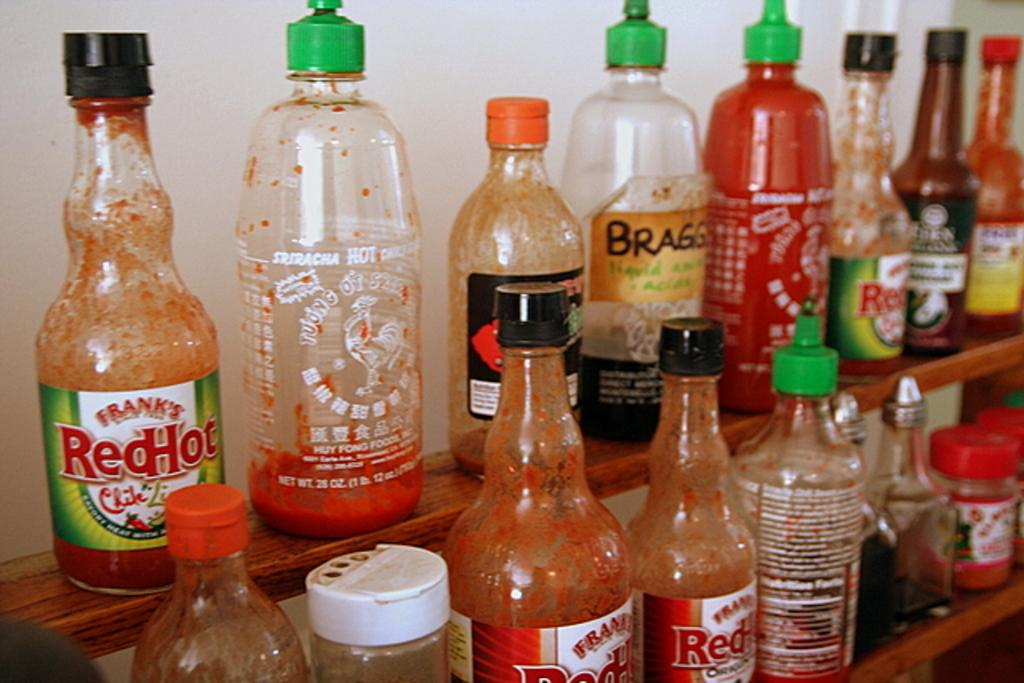What objects are present in the image? There is a group of bottles in the image. How are the bottles arranged or positioned? The bottles are placed on a wooden stand. What type of noise can be heard coming from the field in the image? There is no field present in the image, so it's not possible to determine what, if any, noise might be heard. 